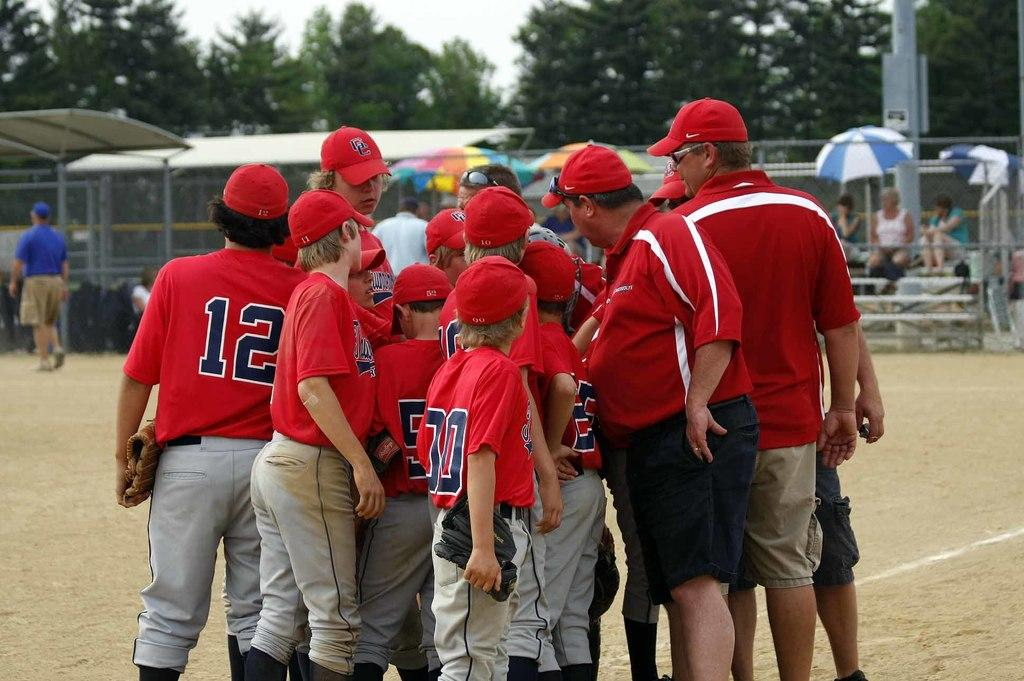<image>
Present a compact description of the photo's key features. A group of baseball players are in a huddle with one of them having the number 12 on his back. 